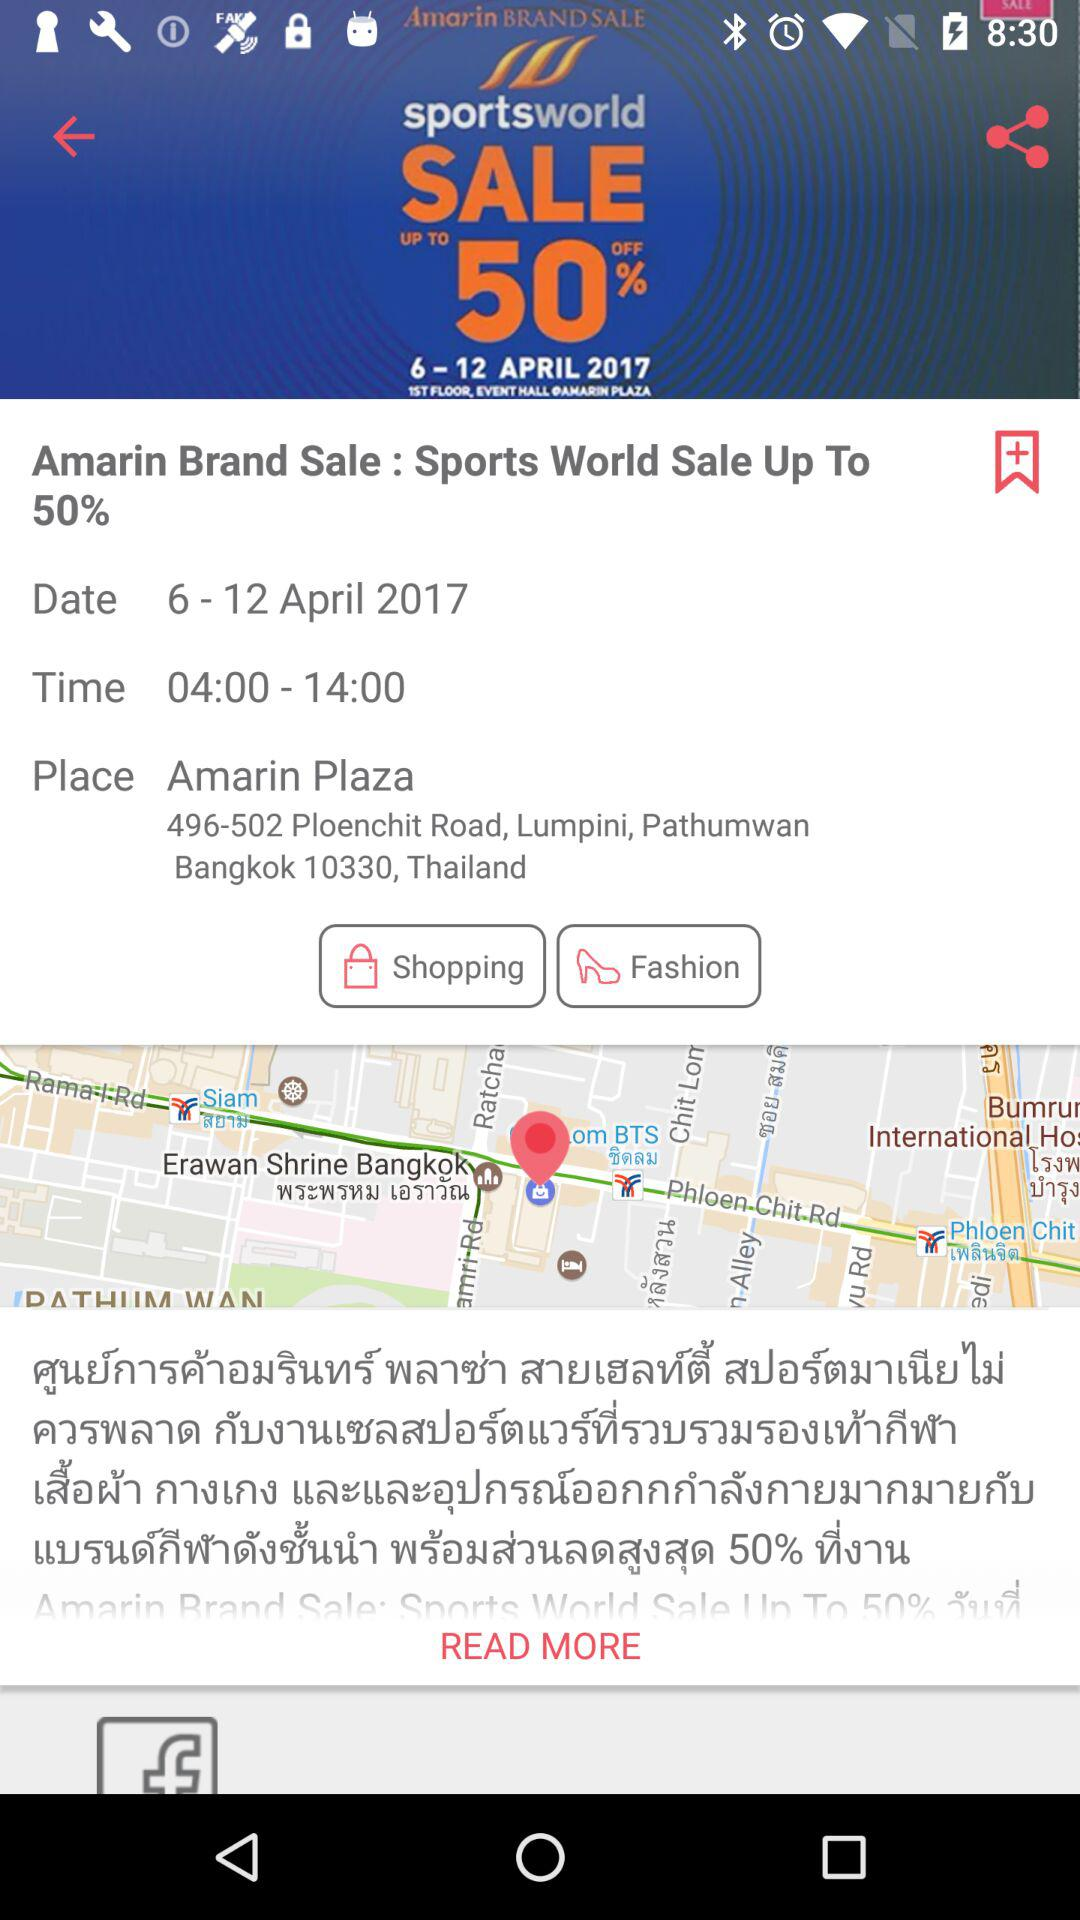How much discount is available on sports world sale? It is up to 50%. 